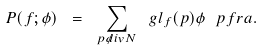Convert formula to latex. <formula><loc_0><loc_0><loc_500><loc_500>P ( f ; \phi ) \ = \ \sum _ { p \not d i v N } \ g l _ { f } ( p ) \phi \ p f r a .</formula> 